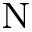<formula> <loc_0><loc_0><loc_500><loc_500>_ { N }</formula> 